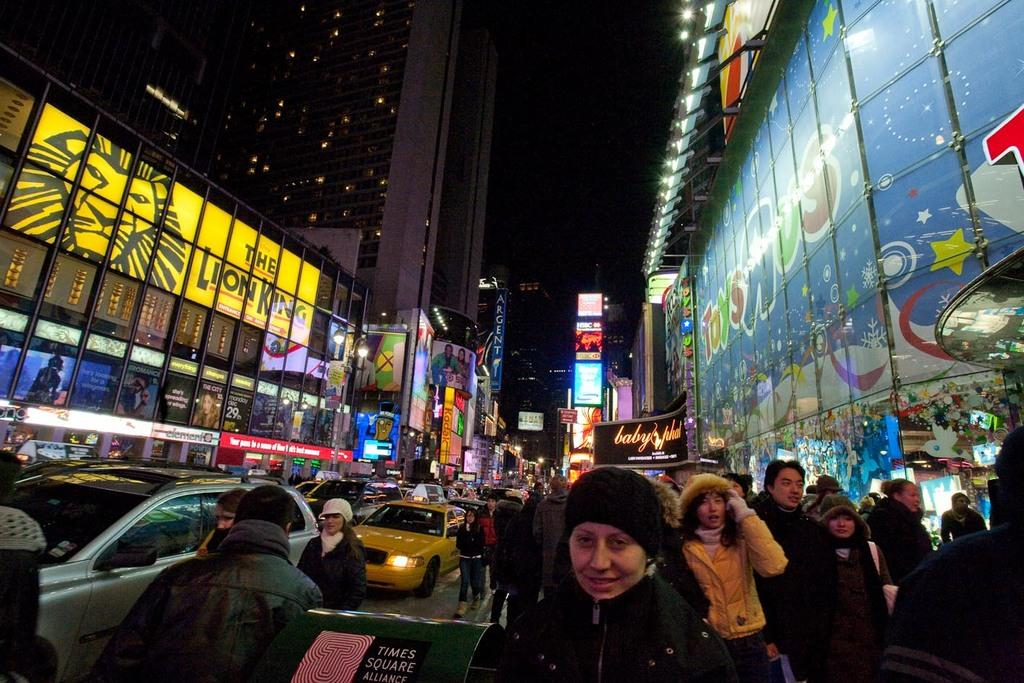How many persons can be seen in the image? There are persons in the image, but the exact number is not specified. What is present on the road in the image? There are vehicles on the road in the image. What can be seen on both sides of the image? There are buildings on the right and left sides of the image. What type of illumination is present in the image? There are lights in the image. What is visible in the background of the image? There is a sky visible in the background of the image. What type of stew is being offered to the persons in the image? There is no stew present in the image, and no offer is being made. What territory is being claimed by the persons in the image? There is no indication of any territory being claimed in the image. 